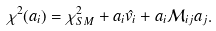Convert formula to latex. <formula><loc_0><loc_0><loc_500><loc_500>\chi ^ { 2 } ( a _ { i } ) = \chi ^ { 2 } _ { S M } + a _ { i } \hat { v _ { i } } + a _ { i } { \mathcal { M } } _ { i j } a _ { j } .</formula> 